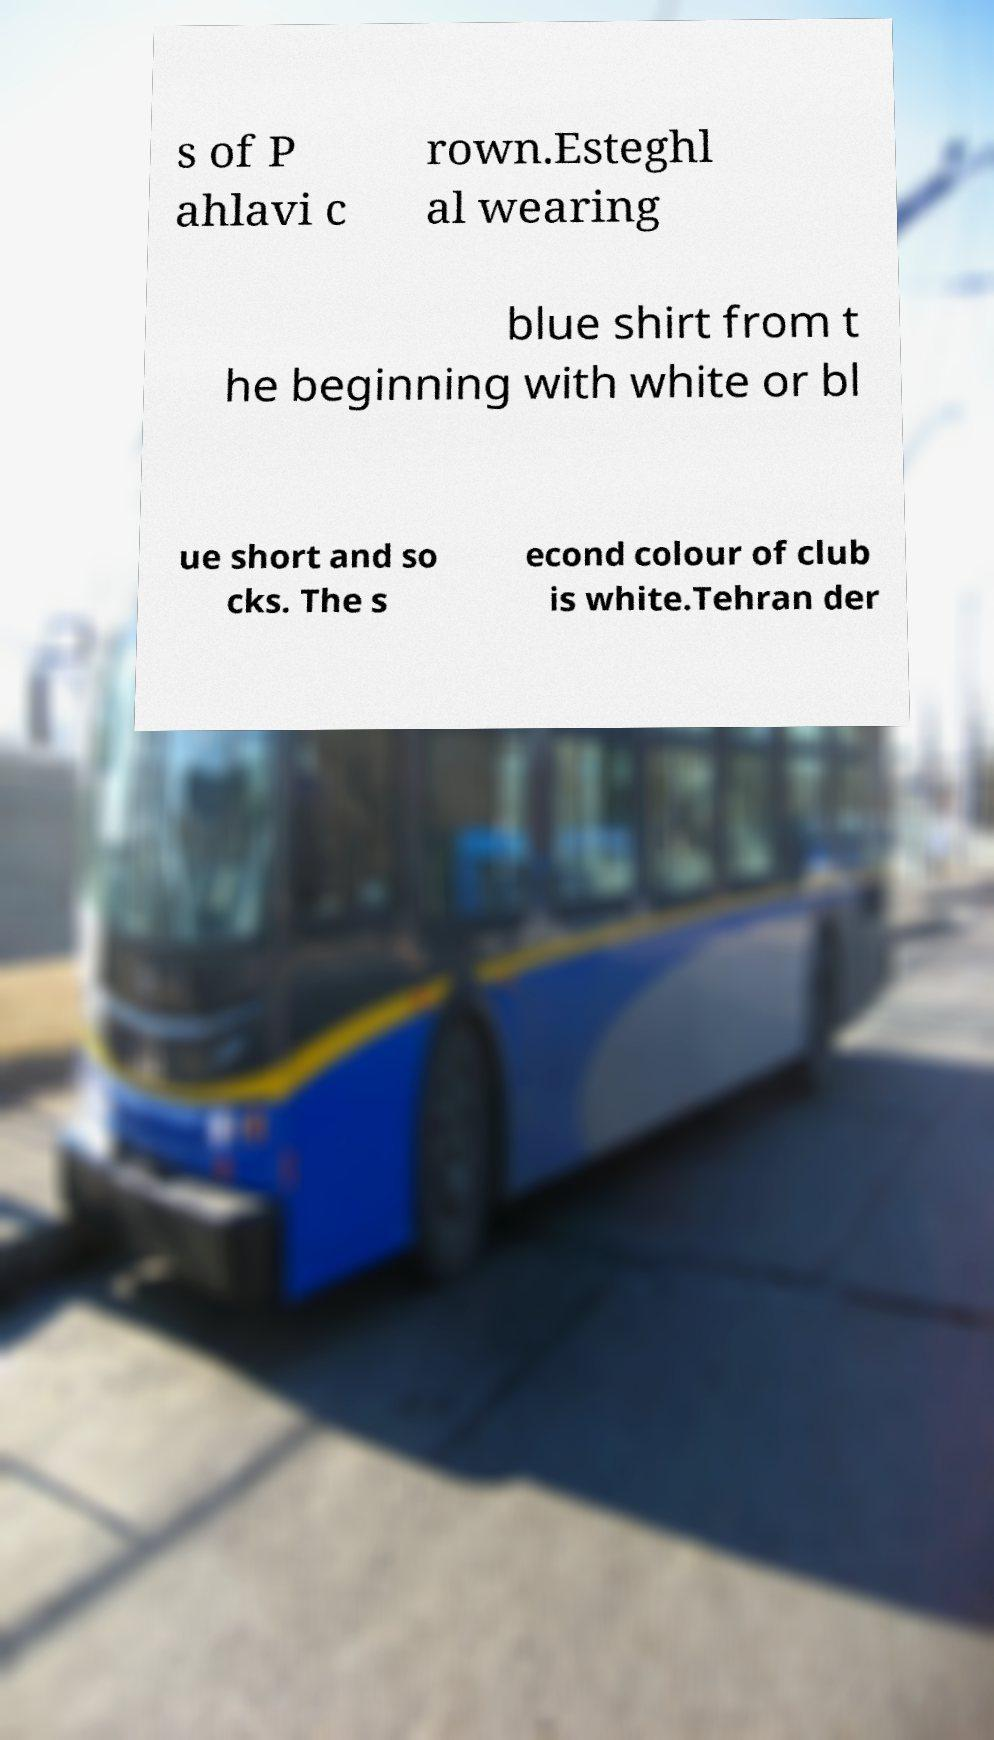I need the written content from this picture converted into text. Can you do that? s of P ahlavi c rown.Esteghl al wearing blue shirt from t he beginning with white or bl ue short and so cks. The s econd colour of club is white.Tehran der 